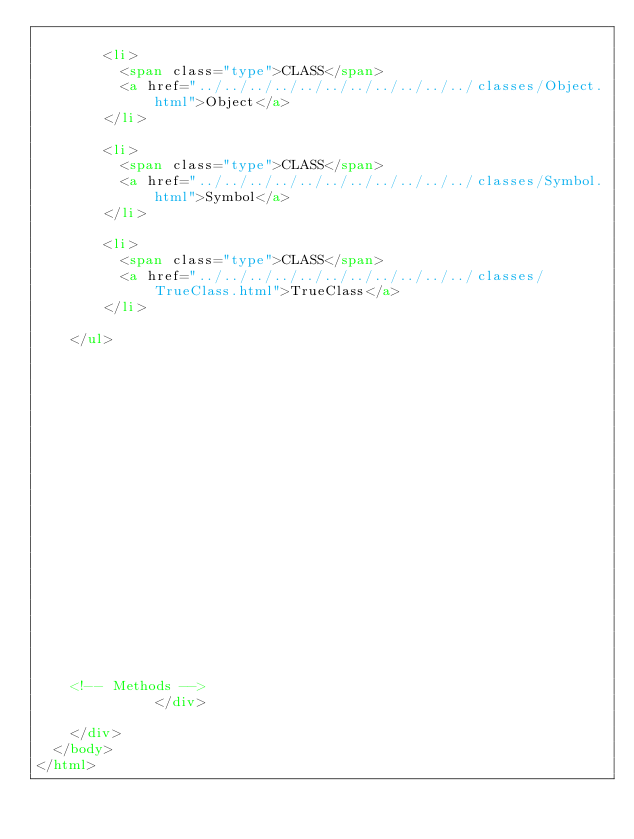Convert code to text. <code><loc_0><loc_0><loc_500><loc_500><_HTML_>      
        <li>
          <span class="type">CLASS</span>
          <a href="../../../../../../../../../../../classes/Object.html">Object</a>
        </li>
      
        <li>
          <span class="type">CLASS</span>
          <a href="../../../../../../../../../../../classes/Symbol.html">Symbol</a>
        </li>
      
        <li>
          <span class="type">CLASS</span>
          <a href="../../../../../../../../../../../classes/TrueClass.html">TrueClass</a>
        </li>
      
    </ul>
  


  

  



  

    

    

    


    


    <!-- Methods -->
              </div>

    </div>
  </body>
</html></code> 